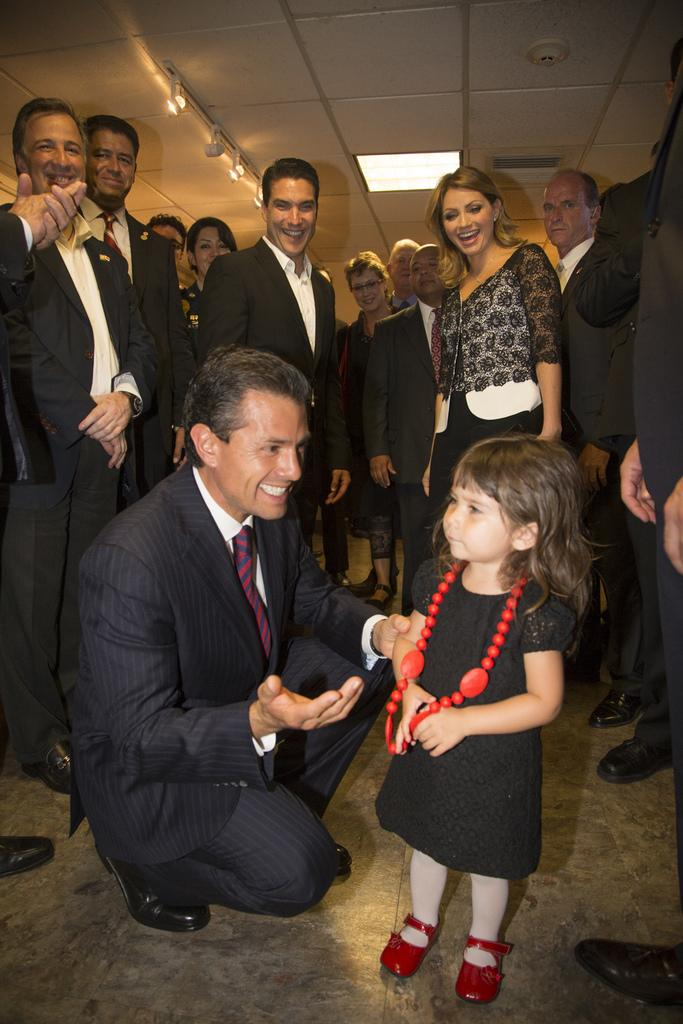Who are the main subjects in the image? There is a man and a small girl in the image. Where are the man and the small girl located in the image? The man and the small girl are in the center of the image. Are there any other people visible in the image? Yes, there are other people in the background of the image. What type of meat is the fireman cooking in the image? There is no fireman or meat present in the image. The image features a man and a small girl in the center, with other people in the background. 